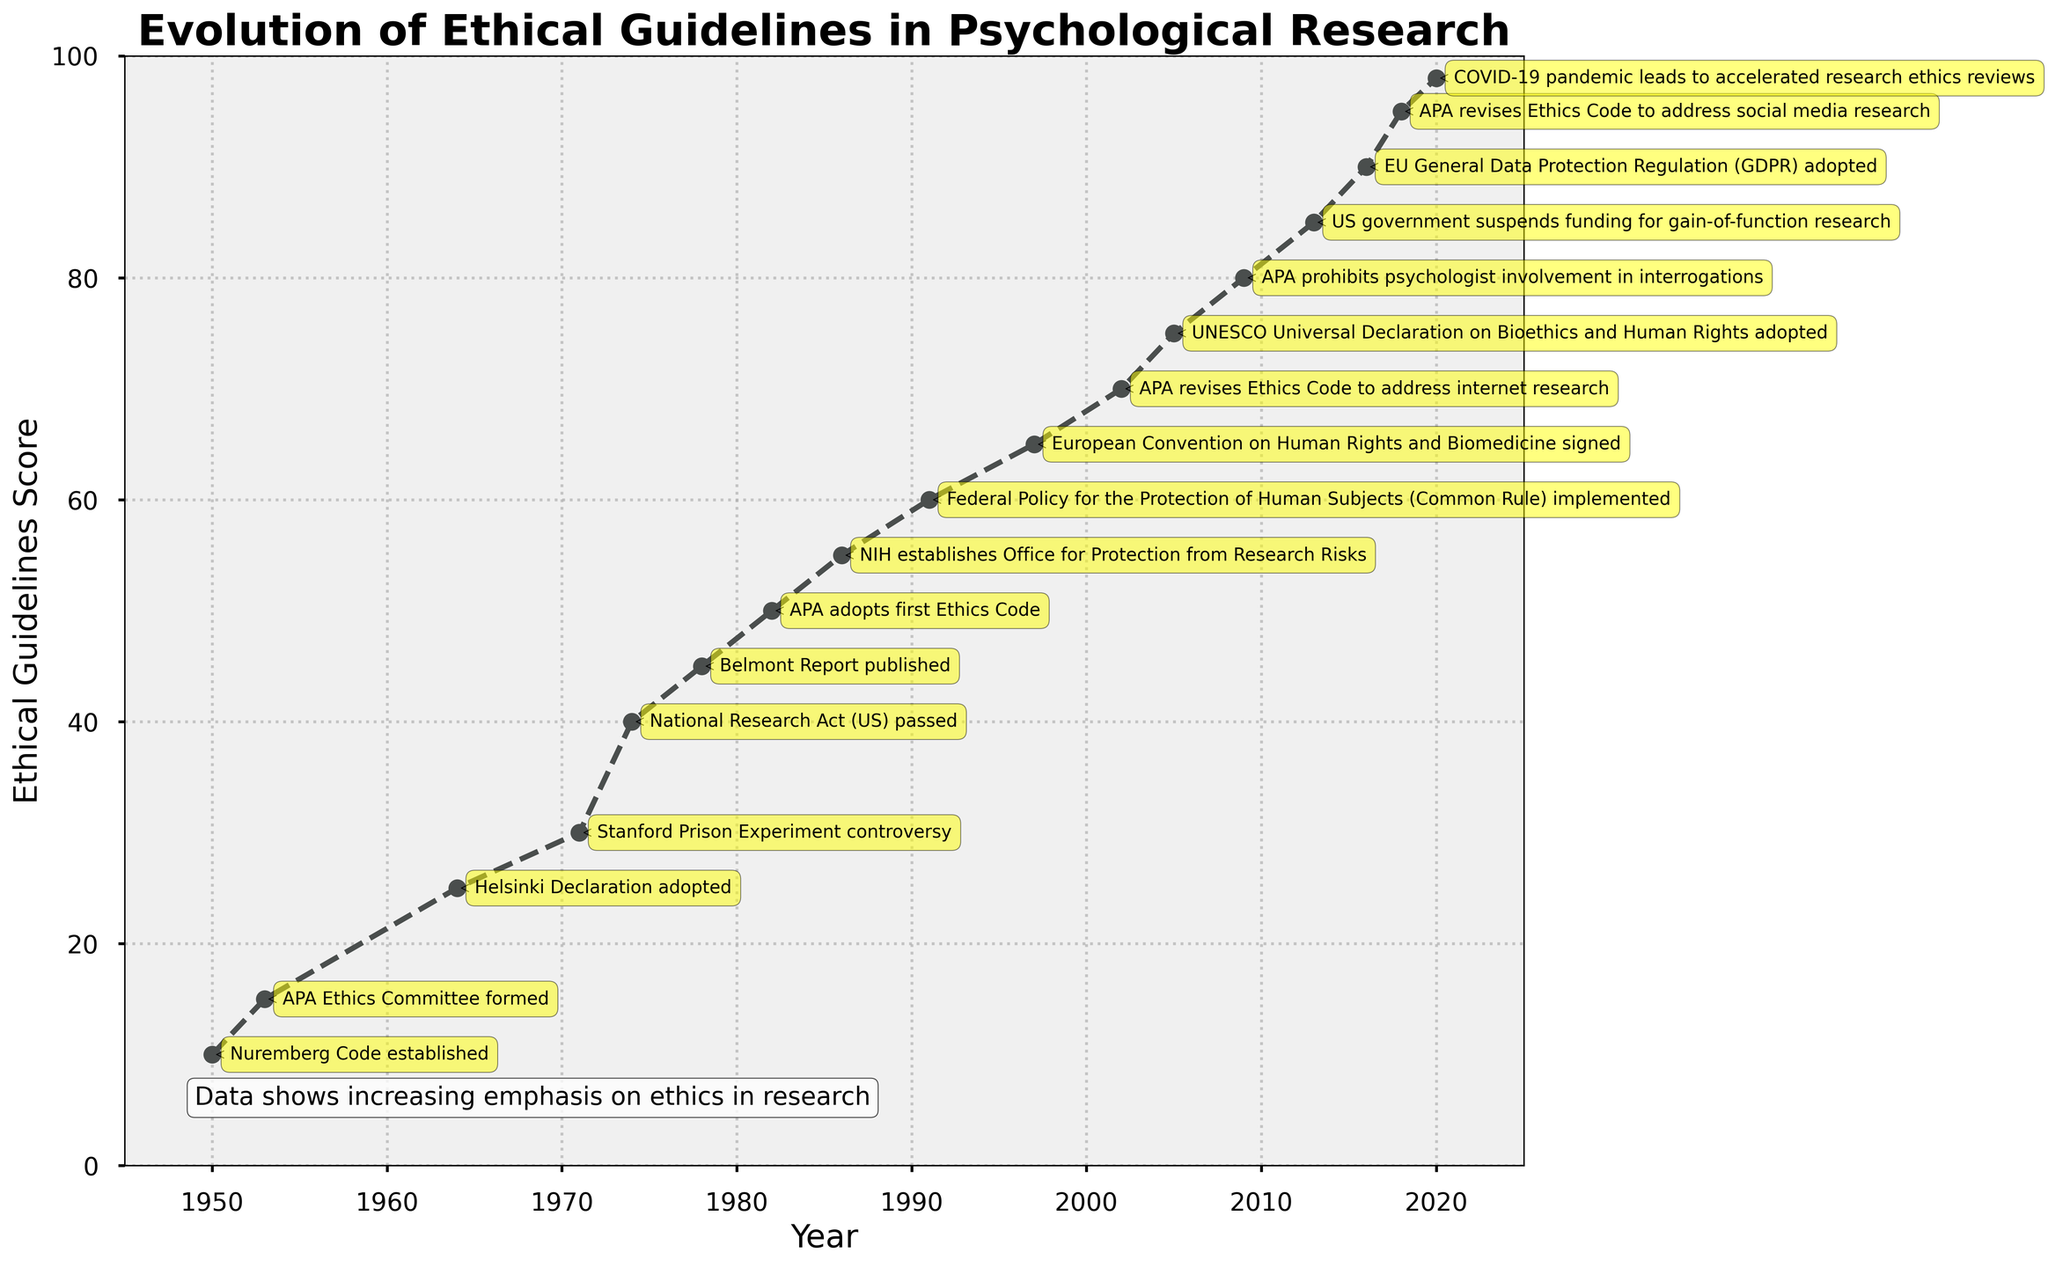What is the score of ethical guidelines in 1982? The score of the ethical guidelines can be found directly from the figure by locating the year 1982 on the x-axis and checking the corresponding value on the y-axis.
Answer: 50 Which year shows the highest Ethical Guidelines Score? The highest Ethical Guidelines Score is represented by the highest y-axis value on the plot.
Answer: 2020 How much did the Ethical Guidelines Score change between 1953 and 1964? To calculate the change, find the scores for 1953 and 1964 from the figure and subtract the former from the latter: 25 - 15 = 10.
Answer: 10 Between which years did the largest single increase in the Ethical Guidelines Score occur? The largest single increase can be determined by examining the differences in scores between consecutive years and identifying the greatest increase. The largest jump is from 1974 (score 40) to 1978 (score 45), an increase of 20.
Answer: 1978 What milestone corresponds with the score of 60? Identify the score of 60 on the y-axis and trace it back to the year on the x-axis. The corresponding milestone is related to that year.
Answer: Federal Policy for the Protection of Human Subjects (Common Rule) implemented Compare the Ethical Guidelines Scores in 1950 and 2020. How much higher is the score in 2020? Identify the scores for 1950 and 2020. Subtract the 1950 score from the 2020 score: 98 - 10 = 88.
Answer: 88 What trend is indicated by the overall direction of the Ethical Guidelines Score over time? The line graph shows an upward trend from left (1950) to right (2020), indicating a continuous improvement in ethical guidelines over this period.
Answer: Continuous improvement How many significant policy changes or milestones are annotated on the plot? Count the number of annotation points mentioned in the plot.
Answer: 13 What was the ethical score increase associated with the adoption of the Helsinki Declaration in 1964? Find the difference between the score in 1964 and the previous milestone in 1953: 25 - 15 = 10.
Answer: 10 What pattern do the marks and annotations on the plot suggest about the frequency of major milestones in psychological research ethics? The marks and annotations suggest that major milestones became more frequent starting in the 1970s, indicating an accelerating rate of policy and milestone developments over time.
Answer: More frequent since the 1970s 